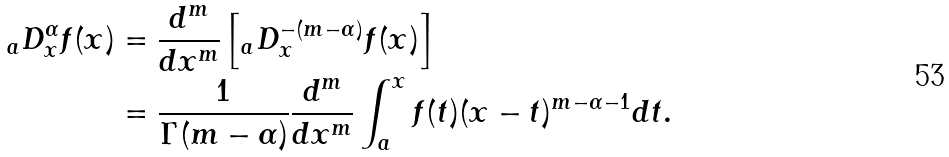<formula> <loc_0><loc_0><loc_500><loc_500>{ _ { a } D _ { x } ^ { \alpha } } f ( x ) & = \frac { d ^ { m } } { d x ^ { m } } \left [ { _ { a } D _ { x } ^ { - ( m - \alpha ) } } f ( x ) \right ] \\ & = \frac { 1 } { \Gamma ( m - \alpha ) } \frac { d ^ { m } } { d x ^ { m } } \int _ { a } ^ { x } f ( t ) ( x - t ) ^ { m - \alpha - 1 } d t .</formula> 